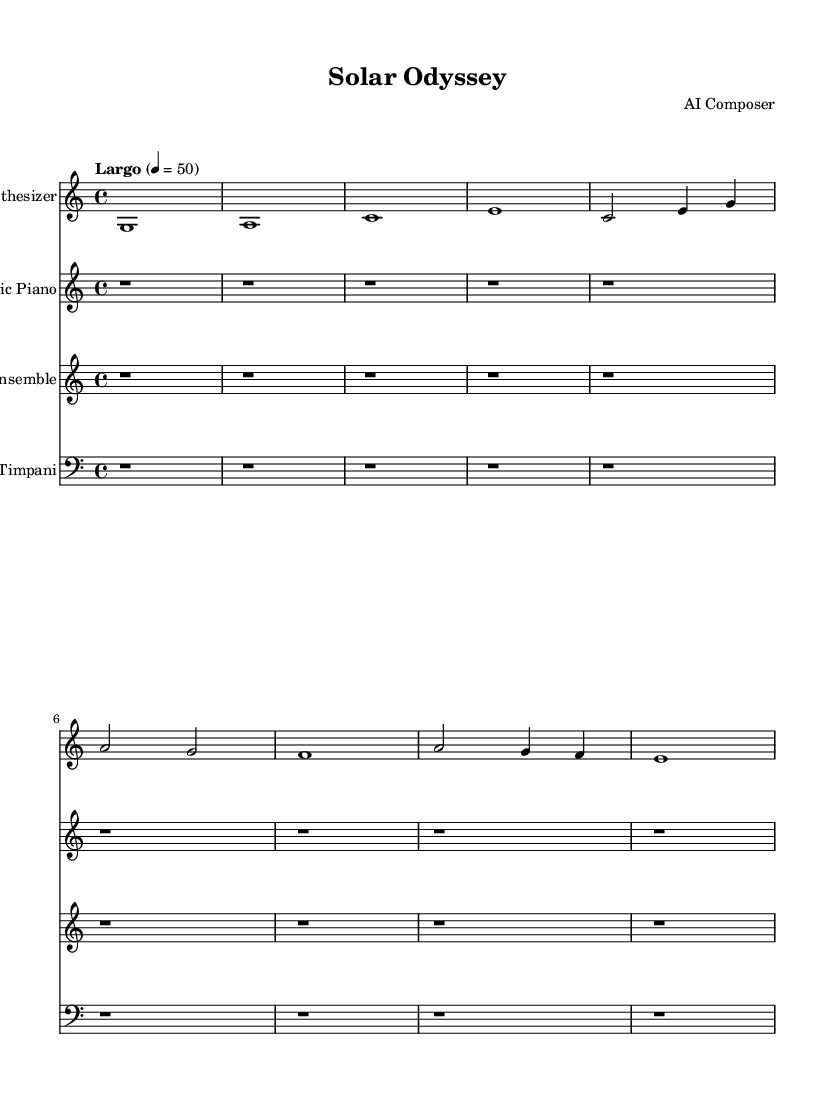What is the key signature of this music? The key signature is C major, which has no sharps or flats, indicated at the beginning of the staff.
Answer: C major What is the time signature of this music? The time signature is 4/4, which is shown at the beginning of the piece, indicating four beats per measure.
Answer: 4/4 What is the tempo marking of this music? The tempo marking indicates "Largo," meaning it should be played slowly, with a quarter note equal to 50.
Answer: Largo How many measures are used in the synthesizer part? The synthesizer part consists of four measures, as indicated by the distinct musical phrases separated by bar lines.
Answer: 4 What instruments are included in this score? The instruments notated in the score are synthesizer, electric piano, string ensemble, and timpani, each represented with its own staff.
Answer: Synthesizer, electric piano, string ensemble, timpani What is the note value of the longest note in the main synthesizer line? The longest note in the synthesizer line is a whole note, as indicated by the note duration that lasts for four beats.
Answer: Whole note Which instrument has a rest for the entirety of the score? The electric piano, as indicated by the repeated whole rests throughout its part, suggesting no sound should be produced.
Answer: Electric piano 